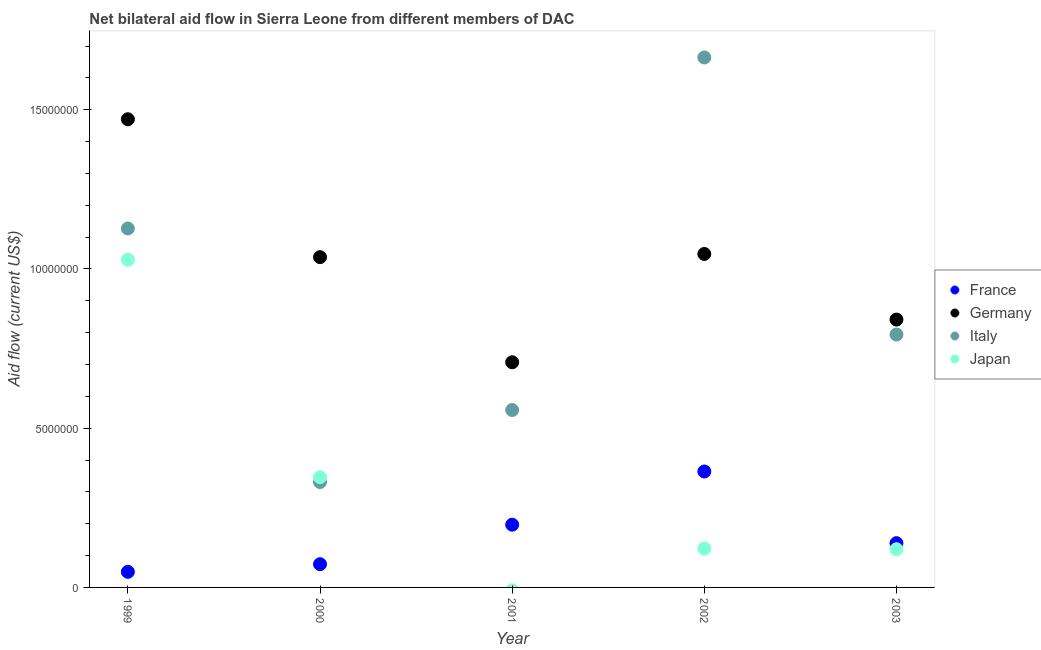How many different coloured dotlines are there?
Your answer should be compact. 4. Is the number of dotlines equal to the number of legend labels?
Your answer should be compact. No. What is the amount of aid given by germany in 2001?
Offer a terse response. 7.07e+06. Across all years, what is the maximum amount of aid given by italy?
Your response must be concise. 1.66e+07. Across all years, what is the minimum amount of aid given by italy?
Your response must be concise. 3.31e+06. What is the total amount of aid given by germany in the graph?
Your answer should be compact. 5.10e+07. What is the difference between the amount of aid given by germany in 2000 and that in 2003?
Provide a short and direct response. 1.96e+06. What is the difference between the amount of aid given by france in 2003 and the amount of aid given by germany in 2000?
Keep it short and to the point. -8.98e+06. What is the average amount of aid given by italy per year?
Give a very brief answer. 8.95e+06. In the year 1999, what is the difference between the amount of aid given by germany and amount of aid given by japan?
Provide a short and direct response. 4.41e+06. What is the ratio of the amount of aid given by france in 2000 to that in 2002?
Provide a succinct answer. 0.2. What is the difference between the highest and the second highest amount of aid given by italy?
Ensure brevity in your answer.  5.37e+06. What is the difference between the highest and the lowest amount of aid given by france?
Offer a terse response. 3.15e+06. In how many years, is the amount of aid given by italy greater than the average amount of aid given by italy taken over all years?
Ensure brevity in your answer.  2. Is it the case that in every year, the sum of the amount of aid given by italy and amount of aid given by france is greater than the sum of amount of aid given by germany and amount of aid given by japan?
Give a very brief answer. No. Is it the case that in every year, the sum of the amount of aid given by france and amount of aid given by germany is greater than the amount of aid given by italy?
Your response must be concise. No. Does the amount of aid given by japan monotonically increase over the years?
Ensure brevity in your answer.  No. Is the amount of aid given by france strictly greater than the amount of aid given by italy over the years?
Provide a succinct answer. No. Is the amount of aid given by japan strictly less than the amount of aid given by germany over the years?
Give a very brief answer. Yes. How many years are there in the graph?
Your answer should be very brief. 5. What is the difference between two consecutive major ticks on the Y-axis?
Make the answer very short. 5.00e+06. Does the graph contain any zero values?
Provide a succinct answer. Yes. Does the graph contain grids?
Ensure brevity in your answer.  No. Where does the legend appear in the graph?
Your answer should be very brief. Center right. How many legend labels are there?
Your answer should be compact. 4. How are the legend labels stacked?
Offer a terse response. Vertical. What is the title of the graph?
Give a very brief answer. Net bilateral aid flow in Sierra Leone from different members of DAC. Does "Other greenhouse gases" appear as one of the legend labels in the graph?
Keep it short and to the point. No. What is the label or title of the X-axis?
Your response must be concise. Year. What is the label or title of the Y-axis?
Provide a succinct answer. Aid flow (current US$). What is the Aid flow (current US$) of Germany in 1999?
Keep it short and to the point. 1.47e+07. What is the Aid flow (current US$) in Italy in 1999?
Make the answer very short. 1.13e+07. What is the Aid flow (current US$) in Japan in 1999?
Make the answer very short. 1.03e+07. What is the Aid flow (current US$) of France in 2000?
Keep it short and to the point. 7.30e+05. What is the Aid flow (current US$) in Germany in 2000?
Make the answer very short. 1.04e+07. What is the Aid flow (current US$) of Italy in 2000?
Provide a succinct answer. 3.31e+06. What is the Aid flow (current US$) of Japan in 2000?
Ensure brevity in your answer.  3.46e+06. What is the Aid flow (current US$) in France in 2001?
Give a very brief answer. 1.97e+06. What is the Aid flow (current US$) of Germany in 2001?
Keep it short and to the point. 7.07e+06. What is the Aid flow (current US$) of Italy in 2001?
Your response must be concise. 5.57e+06. What is the Aid flow (current US$) of Japan in 2001?
Keep it short and to the point. 0. What is the Aid flow (current US$) in France in 2002?
Make the answer very short. 3.64e+06. What is the Aid flow (current US$) in Germany in 2002?
Keep it short and to the point. 1.05e+07. What is the Aid flow (current US$) of Italy in 2002?
Provide a short and direct response. 1.66e+07. What is the Aid flow (current US$) in Japan in 2002?
Provide a succinct answer. 1.22e+06. What is the Aid flow (current US$) in France in 2003?
Keep it short and to the point. 1.39e+06. What is the Aid flow (current US$) of Germany in 2003?
Make the answer very short. 8.41e+06. What is the Aid flow (current US$) in Italy in 2003?
Give a very brief answer. 7.94e+06. What is the Aid flow (current US$) in Japan in 2003?
Keep it short and to the point. 1.20e+06. Across all years, what is the maximum Aid flow (current US$) in France?
Make the answer very short. 3.64e+06. Across all years, what is the maximum Aid flow (current US$) in Germany?
Ensure brevity in your answer.  1.47e+07. Across all years, what is the maximum Aid flow (current US$) of Italy?
Your answer should be compact. 1.66e+07. Across all years, what is the maximum Aid flow (current US$) in Japan?
Keep it short and to the point. 1.03e+07. Across all years, what is the minimum Aid flow (current US$) in Germany?
Ensure brevity in your answer.  7.07e+06. Across all years, what is the minimum Aid flow (current US$) in Italy?
Ensure brevity in your answer.  3.31e+06. Across all years, what is the minimum Aid flow (current US$) of Japan?
Provide a short and direct response. 0. What is the total Aid flow (current US$) of France in the graph?
Give a very brief answer. 8.22e+06. What is the total Aid flow (current US$) of Germany in the graph?
Your answer should be compact. 5.10e+07. What is the total Aid flow (current US$) of Italy in the graph?
Offer a terse response. 4.47e+07. What is the total Aid flow (current US$) of Japan in the graph?
Provide a succinct answer. 1.62e+07. What is the difference between the Aid flow (current US$) of France in 1999 and that in 2000?
Your answer should be compact. -2.40e+05. What is the difference between the Aid flow (current US$) in Germany in 1999 and that in 2000?
Keep it short and to the point. 4.33e+06. What is the difference between the Aid flow (current US$) in Italy in 1999 and that in 2000?
Your answer should be compact. 7.96e+06. What is the difference between the Aid flow (current US$) of Japan in 1999 and that in 2000?
Provide a short and direct response. 6.83e+06. What is the difference between the Aid flow (current US$) of France in 1999 and that in 2001?
Offer a terse response. -1.48e+06. What is the difference between the Aid flow (current US$) in Germany in 1999 and that in 2001?
Offer a very short reply. 7.63e+06. What is the difference between the Aid flow (current US$) of Italy in 1999 and that in 2001?
Ensure brevity in your answer.  5.70e+06. What is the difference between the Aid flow (current US$) in France in 1999 and that in 2002?
Your response must be concise. -3.15e+06. What is the difference between the Aid flow (current US$) of Germany in 1999 and that in 2002?
Provide a succinct answer. 4.23e+06. What is the difference between the Aid flow (current US$) in Italy in 1999 and that in 2002?
Your answer should be very brief. -5.37e+06. What is the difference between the Aid flow (current US$) in Japan in 1999 and that in 2002?
Provide a succinct answer. 9.07e+06. What is the difference between the Aid flow (current US$) of France in 1999 and that in 2003?
Give a very brief answer. -9.00e+05. What is the difference between the Aid flow (current US$) of Germany in 1999 and that in 2003?
Make the answer very short. 6.29e+06. What is the difference between the Aid flow (current US$) in Italy in 1999 and that in 2003?
Keep it short and to the point. 3.33e+06. What is the difference between the Aid flow (current US$) in Japan in 1999 and that in 2003?
Your answer should be very brief. 9.09e+06. What is the difference between the Aid flow (current US$) in France in 2000 and that in 2001?
Give a very brief answer. -1.24e+06. What is the difference between the Aid flow (current US$) of Germany in 2000 and that in 2001?
Offer a terse response. 3.30e+06. What is the difference between the Aid flow (current US$) in Italy in 2000 and that in 2001?
Provide a succinct answer. -2.26e+06. What is the difference between the Aid flow (current US$) in France in 2000 and that in 2002?
Provide a short and direct response. -2.91e+06. What is the difference between the Aid flow (current US$) of Germany in 2000 and that in 2002?
Keep it short and to the point. -1.00e+05. What is the difference between the Aid flow (current US$) of Italy in 2000 and that in 2002?
Provide a succinct answer. -1.33e+07. What is the difference between the Aid flow (current US$) of Japan in 2000 and that in 2002?
Keep it short and to the point. 2.24e+06. What is the difference between the Aid flow (current US$) of France in 2000 and that in 2003?
Give a very brief answer. -6.60e+05. What is the difference between the Aid flow (current US$) in Germany in 2000 and that in 2003?
Your response must be concise. 1.96e+06. What is the difference between the Aid flow (current US$) in Italy in 2000 and that in 2003?
Offer a very short reply. -4.63e+06. What is the difference between the Aid flow (current US$) in Japan in 2000 and that in 2003?
Make the answer very short. 2.26e+06. What is the difference between the Aid flow (current US$) of France in 2001 and that in 2002?
Offer a terse response. -1.67e+06. What is the difference between the Aid flow (current US$) in Germany in 2001 and that in 2002?
Give a very brief answer. -3.40e+06. What is the difference between the Aid flow (current US$) in Italy in 2001 and that in 2002?
Offer a terse response. -1.11e+07. What is the difference between the Aid flow (current US$) of France in 2001 and that in 2003?
Keep it short and to the point. 5.80e+05. What is the difference between the Aid flow (current US$) in Germany in 2001 and that in 2003?
Your answer should be very brief. -1.34e+06. What is the difference between the Aid flow (current US$) of Italy in 2001 and that in 2003?
Your answer should be compact. -2.37e+06. What is the difference between the Aid flow (current US$) of France in 2002 and that in 2003?
Offer a very short reply. 2.25e+06. What is the difference between the Aid flow (current US$) in Germany in 2002 and that in 2003?
Give a very brief answer. 2.06e+06. What is the difference between the Aid flow (current US$) of Italy in 2002 and that in 2003?
Provide a short and direct response. 8.70e+06. What is the difference between the Aid flow (current US$) of France in 1999 and the Aid flow (current US$) of Germany in 2000?
Provide a short and direct response. -9.88e+06. What is the difference between the Aid flow (current US$) of France in 1999 and the Aid flow (current US$) of Italy in 2000?
Your answer should be compact. -2.82e+06. What is the difference between the Aid flow (current US$) of France in 1999 and the Aid flow (current US$) of Japan in 2000?
Offer a very short reply. -2.97e+06. What is the difference between the Aid flow (current US$) of Germany in 1999 and the Aid flow (current US$) of Italy in 2000?
Ensure brevity in your answer.  1.14e+07. What is the difference between the Aid flow (current US$) of Germany in 1999 and the Aid flow (current US$) of Japan in 2000?
Provide a succinct answer. 1.12e+07. What is the difference between the Aid flow (current US$) in Italy in 1999 and the Aid flow (current US$) in Japan in 2000?
Make the answer very short. 7.81e+06. What is the difference between the Aid flow (current US$) of France in 1999 and the Aid flow (current US$) of Germany in 2001?
Provide a short and direct response. -6.58e+06. What is the difference between the Aid flow (current US$) of France in 1999 and the Aid flow (current US$) of Italy in 2001?
Give a very brief answer. -5.08e+06. What is the difference between the Aid flow (current US$) of Germany in 1999 and the Aid flow (current US$) of Italy in 2001?
Provide a short and direct response. 9.13e+06. What is the difference between the Aid flow (current US$) in France in 1999 and the Aid flow (current US$) in Germany in 2002?
Your response must be concise. -9.98e+06. What is the difference between the Aid flow (current US$) in France in 1999 and the Aid flow (current US$) in Italy in 2002?
Provide a succinct answer. -1.62e+07. What is the difference between the Aid flow (current US$) of France in 1999 and the Aid flow (current US$) of Japan in 2002?
Your response must be concise. -7.30e+05. What is the difference between the Aid flow (current US$) in Germany in 1999 and the Aid flow (current US$) in Italy in 2002?
Ensure brevity in your answer.  -1.94e+06. What is the difference between the Aid flow (current US$) in Germany in 1999 and the Aid flow (current US$) in Japan in 2002?
Provide a short and direct response. 1.35e+07. What is the difference between the Aid flow (current US$) of Italy in 1999 and the Aid flow (current US$) of Japan in 2002?
Make the answer very short. 1.00e+07. What is the difference between the Aid flow (current US$) of France in 1999 and the Aid flow (current US$) of Germany in 2003?
Your answer should be very brief. -7.92e+06. What is the difference between the Aid flow (current US$) of France in 1999 and the Aid flow (current US$) of Italy in 2003?
Make the answer very short. -7.45e+06. What is the difference between the Aid flow (current US$) in France in 1999 and the Aid flow (current US$) in Japan in 2003?
Offer a terse response. -7.10e+05. What is the difference between the Aid flow (current US$) of Germany in 1999 and the Aid flow (current US$) of Italy in 2003?
Give a very brief answer. 6.76e+06. What is the difference between the Aid flow (current US$) in Germany in 1999 and the Aid flow (current US$) in Japan in 2003?
Offer a terse response. 1.35e+07. What is the difference between the Aid flow (current US$) of Italy in 1999 and the Aid flow (current US$) of Japan in 2003?
Your answer should be compact. 1.01e+07. What is the difference between the Aid flow (current US$) of France in 2000 and the Aid flow (current US$) of Germany in 2001?
Provide a succinct answer. -6.34e+06. What is the difference between the Aid flow (current US$) in France in 2000 and the Aid flow (current US$) in Italy in 2001?
Your answer should be compact. -4.84e+06. What is the difference between the Aid flow (current US$) of Germany in 2000 and the Aid flow (current US$) of Italy in 2001?
Your response must be concise. 4.80e+06. What is the difference between the Aid flow (current US$) in France in 2000 and the Aid flow (current US$) in Germany in 2002?
Offer a terse response. -9.74e+06. What is the difference between the Aid flow (current US$) in France in 2000 and the Aid flow (current US$) in Italy in 2002?
Your answer should be compact. -1.59e+07. What is the difference between the Aid flow (current US$) in France in 2000 and the Aid flow (current US$) in Japan in 2002?
Offer a very short reply. -4.90e+05. What is the difference between the Aid flow (current US$) in Germany in 2000 and the Aid flow (current US$) in Italy in 2002?
Provide a short and direct response. -6.27e+06. What is the difference between the Aid flow (current US$) of Germany in 2000 and the Aid flow (current US$) of Japan in 2002?
Provide a short and direct response. 9.15e+06. What is the difference between the Aid flow (current US$) in Italy in 2000 and the Aid flow (current US$) in Japan in 2002?
Give a very brief answer. 2.09e+06. What is the difference between the Aid flow (current US$) in France in 2000 and the Aid flow (current US$) in Germany in 2003?
Offer a terse response. -7.68e+06. What is the difference between the Aid flow (current US$) of France in 2000 and the Aid flow (current US$) of Italy in 2003?
Your answer should be compact. -7.21e+06. What is the difference between the Aid flow (current US$) in France in 2000 and the Aid flow (current US$) in Japan in 2003?
Offer a very short reply. -4.70e+05. What is the difference between the Aid flow (current US$) of Germany in 2000 and the Aid flow (current US$) of Italy in 2003?
Your answer should be very brief. 2.43e+06. What is the difference between the Aid flow (current US$) of Germany in 2000 and the Aid flow (current US$) of Japan in 2003?
Give a very brief answer. 9.17e+06. What is the difference between the Aid flow (current US$) in Italy in 2000 and the Aid flow (current US$) in Japan in 2003?
Your answer should be compact. 2.11e+06. What is the difference between the Aid flow (current US$) of France in 2001 and the Aid flow (current US$) of Germany in 2002?
Your answer should be compact. -8.50e+06. What is the difference between the Aid flow (current US$) of France in 2001 and the Aid flow (current US$) of Italy in 2002?
Your response must be concise. -1.47e+07. What is the difference between the Aid flow (current US$) in France in 2001 and the Aid flow (current US$) in Japan in 2002?
Your answer should be very brief. 7.50e+05. What is the difference between the Aid flow (current US$) in Germany in 2001 and the Aid flow (current US$) in Italy in 2002?
Ensure brevity in your answer.  -9.57e+06. What is the difference between the Aid flow (current US$) in Germany in 2001 and the Aid flow (current US$) in Japan in 2002?
Offer a very short reply. 5.85e+06. What is the difference between the Aid flow (current US$) in Italy in 2001 and the Aid flow (current US$) in Japan in 2002?
Keep it short and to the point. 4.35e+06. What is the difference between the Aid flow (current US$) in France in 2001 and the Aid flow (current US$) in Germany in 2003?
Your answer should be very brief. -6.44e+06. What is the difference between the Aid flow (current US$) of France in 2001 and the Aid flow (current US$) of Italy in 2003?
Keep it short and to the point. -5.97e+06. What is the difference between the Aid flow (current US$) in France in 2001 and the Aid flow (current US$) in Japan in 2003?
Your answer should be very brief. 7.70e+05. What is the difference between the Aid flow (current US$) of Germany in 2001 and the Aid flow (current US$) of Italy in 2003?
Your answer should be compact. -8.70e+05. What is the difference between the Aid flow (current US$) in Germany in 2001 and the Aid flow (current US$) in Japan in 2003?
Offer a terse response. 5.87e+06. What is the difference between the Aid flow (current US$) in Italy in 2001 and the Aid flow (current US$) in Japan in 2003?
Your response must be concise. 4.37e+06. What is the difference between the Aid flow (current US$) in France in 2002 and the Aid flow (current US$) in Germany in 2003?
Provide a succinct answer. -4.77e+06. What is the difference between the Aid flow (current US$) of France in 2002 and the Aid flow (current US$) of Italy in 2003?
Provide a short and direct response. -4.30e+06. What is the difference between the Aid flow (current US$) in France in 2002 and the Aid flow (current US$) in Japan in 2003?
Give a very brief answer. 2.44e+06. What is the difference between the Aid flow (current US$) of Germany in 2002 and the Aid flow (current US$) of Italy in 2003?
Your answer should be compact. 2.53e+06. What is the difference between the Aid flow (current US$) in Germany in 2002 and the Aid flow (current US$) in Japan in 2003?
Your answer should be compact. 9.27e+06. What is the difference between the Aid flow (current US$) in Italy in 2002 and the Aid flow (current US$) in Japan in 2003?
Make the answer very short. 1.54e+07. What is the average Aid flow (current US$) in France per year?
Provide a short and direct response. 1.64e+06. What is the average Aid flow (current US$) of Germany per year?
Give a very brief answer. 1.02e+07. What is the average Aid flow (current US$) of Italy per year?
Your response must be concise. 8.95e+06. What is the average Aid flow (current US$) in Japan per year?
Keep it short and to the point. 3.23e+06. In the year 1999, what is the difference between the Aid flow (current US$) of France and Aid flow (current US$) of Germany?
Ensure brevity in your answer.  -1.42e+07. In the year 1999, what is the difference between the Aid flow (current US$) in France and Aid flow (current US$) in Italy?
Provide a succinct answer. -1.08e+07. In the year 1999, what is the difference between the Aid flow (current US$) in France and Aid flow (current US$) in Japan?
Offer a terse response. -9.80e+06. In the year 1999, what is the difference between the Aid flow (current US$) of Germany and Aid flow (current US$) of Italy?
Provide a short and direct response. 3.43e+06. In the year 1999, what is the difference between the Aid flow (current US$) in Germany and Aid flow (current US$) in Japan?
Your answer should be compact. 4.41e+06. In the year 1999, what is the difference between the Aid flow (current US$) of Italy and Aid flow (current US$) of Japan?
Ensure brevity in your answer.  9.80e+05. In the year 2000, what is the difference between the Aid flow (current US$) in France and Aid flow (current US$) in Germany?
Provide a short and direct response. -9.64e+06. In the year 2000, what is the difference between the Aid flow (current US$) in France and Aid flow (current US$) in Italy?
Offer a terse response. -2.58e+06. In the year 2000, what is the difference between the Aid flow (current US$) in France and Aid flow (current US$) in Japan?
Offer a terse response. -2.73e+06. In the year 2000, what is the difference between the Aid flow (current US$) of Germany and Aid flow (current US$) of Italy?
Ensure brevity in your answer.  7.06e+06. In the year 2000, what is the difference between the Aid flow (current US$) of Germany and Aid flow (current US$) of Japan?
Make the answer very short. 6.91e+06. In the year 2000, what is the difference between the Aid flow (current US$) in Italy and Aid flow (current US$) in Japan?
Provide a succinct answer. -1.50e+05. In the year 2001, what is the difference between the Aid flow (current US$) in France and Aid flow (current US$) in Germany?
Give a very brief answer. -5.10e+06. In the year 2001, what is the difference between the Aid flow (current US$) in France and Aid flow (current US$) in Italy?
Your answer should be very brief. -3.60e+06. In the year 2001, what is the difference between the Aid flow (current US$) of Germany and Aid flow (current US$) of Italy?
Give a very brief answer. 1.50e+06. In the year 2002, what is the difference between the Aid flow (current US$) of France and Aid flow (current US$) of Germany?
Your answer should be compact. -6.83e+06. In the year 2002, what is the difference between the Aid flow (current US$) in France and Aid flow (current US$) in Italy?
Your answer should be compact. -1.30e+07. In the year 2002, what is the difference between the Aid flow (current US$) in France and Aid flow (current US$) in Japan?
Provide a short and direct response. 2.42e+06. In the year 2002, what is the difference between the Aid flow (current US$) of Germany and Aid flow (current US$) of Italy?
Offer a terse response. -6.17e+06. In the year 2002, what is the difference between the Aid flow (current US$) in Germany and Aid flow (current US$) in Japan?
Give a very brief answer. 9.25e+06. In the year 2002, what is the difference between the Aid flow (current US$) in Italy and Aid flow (current US$) in Japan?
Ensure brevity in your answer.  1.54e+07. In the year 2003, what is the difference between the Aid flow (current US$) of France and Aid flow (current US$) of Germany?
Ensure brevity in your answer.  -7.02e+06. In the year 2003, what is the difference between the Aid flow (current US$) in France and Aid flow (current US$) in Italy?
Provide a succinct answer. -6.55e+06. In the year 2003, what is the difference between the Aid flow (current US$) of France and Aid flow (current US$) of Japan?
Ensure brevity in your answer.  1.90e+05. In the year 2003, what is the difference between the Aid flow (current US$) of Germany and Aid flow (current US$) of Japan?
Offer a terse response. 7.21e+06. In the year 2003, what is the difference between the Aid flow (current US$) in Italy and Aid flow (current US$) in Japan?
Offer a very short reply. 6.74e+06. What is the ratio of the Aid flow (current US$) in France in 1999 to that in 2000?
Make the answer very short. 0.67. What is the ratio of the Aid flow (current US$) of Germany in 1999 to that in 2000?
Provide a short and direct response. 1.42. What is the ratio of the Aid flow (current US$) in Italy in 1999 to that in 2000?
Provide a short and direct response. 3.4. What is the ratio of the Aid flow (current US$) of Japan in 1999 to that in 2000?
Make the answer very short. 2.97. What is the ratio of the Aid flow (current US$) in France in 1999 to that in 2001?
Offer a very short reply. 0.25. What is the ratio of the Aid flow (current US$) of Germany in 1999 to that in 2001?
Your response must be concise. 2.08. What is the ratio of the Aid flow (current US$) in Italy in 1999 to that in 2001?
Your answer should be compact. 2.02. What is the ratio of the Aid flow (current US$) of France in 1999 to that in 2002?
Your answer should be very brief. 0.13. What is the ratio of the Aid flow (current US$) in Germany in 1999 to that in 2002?
Make the answer very short. 1.4. What is the ratio of the Aid flow (current US$) in Italy in 1999 to that in 2002?
Offer a terse response. 0.68. What is the ratio of the Aid flow (current US$) in Japan in 1999 to that in 2002?
Provide a short and direct response. 8.43. What is the ratio of the Aid flow (current US$) in France in 1999 to that in 2003?
Ensure brevity in your answer.  0.35. What is the ratio of the Aid flow (current US$) in Germany in 1999 to that in 2003?
Make the answer very short. 1.75. What is the ratio of the Aid flow (current US$) of Italy in 1999 to that in 2003?
Your response must be concise. 1.42. What is the ratio of the Aid flow (current US$) of Japan in 1999 to that in 2003?
Ensure brevity in your answer.  8.57. What is the ratio of the Aid flow (current US$) in France in 2000 to that in 2001?
Keep it short and to the point. 0.37. What is the ratio of the Aid flow (current US$) in Germany in 2000 to that in 2001?
Give a very brief answer. 1.47. What is the ratio of the Aid flow (current US$) in Italy in 2000 to that in 2001?
Offer a very short reply. 0.59. What is the ratio of the Aid flow (current US$) of France in 2000 to that in 2002?
Offer a very short reply. 0.2. What is the ratio of the Aid flow (current US$) of Italy in 2000 to that in 2002?
Make the answer very short. 0.2. What is the ratio of the Aid flow (current US$) of Japan in 2000 to that in 2002?
Your answer should be very brief. 2.84. What is the ratio of the Aid flow (current US$) of France in 2000 to that in 2003?
Your answer should be very brief. 0.53. What is the ratio of the Aid flow (current US$) in Germany in 2000 to that in 2003?
Offer a very short reply. 1.23. What is the ratio of the Aid flow (current US$) of Italy in 2000 to that in 2003?
Offer a terse response. 0.42. What is the ratio of the Aid flow (current US$) of Japan in 2000 to that in 2003?
Provide a succinct answer. 2.88. What is the ratio of the Aid flow (current US$) of France in 2001 to that in 2002?
Your answer should be very brief. 0.54. What is the ratio of the Aid flow (current US$) in Germany in 2001 to that in 2002?
Ensure brevity in your answer.  0.68. What is the ratio of the Aid flow (current US$) in Italy in 2001 to that in 2002?
Your response must be concise. 0.33. What is the ratio of the Aid flow (current US$) of France in 2001 to that in 2003?
Your response must be concise. 1.42. What is the ratio of the Aid flow (current US$) of Germany in 2001 to that in 2003?
Give a very brief answer. 0.84. What is the ratio of the Aid flow (current US$) of Italy in 2001 to that in 2003?
Provide a short and direct response. 0.7. What is the ratio of the Aid flow (current US$) of France in 2002 to that in 2003?
Give a very brief answer. 2.62. What is the ratio of the Aid flow (current US$) in Germany in 2002 to that in 2003?
Make the answer very short. 1.24. What is the ratio of the Aid flow (current US$) of Italy in 2002 to that in 2003?
Ensure brevity in your answer.  2.1. What is the ratio of the Aid flow (current US$) in Japan in 2002 to that in 2003?
Your answer should be very brief. 1.02. What is the difference between the highest and the second highest Aid flow (current US$) of France?
Make the answer very short. 1.67e+06. What is the difference between the highest and the second highest Aid flow (current US$) of Germany?
Provide a succinct answer. 4.23e+06. What is the difference between the highest and the second highest Aid flow (current US$) of Italy?
Make the answer very short. 5.37e+06. What is the difference between the highest and the second highest Aid flow (current US$) of Japan?
Offer a very short reply. 6.83e+06. What is the difference between the highest and the lowest Aid flow (current US$) of France?
Offer a terse response. 3.15e+06. What is the difference between the highest and the lowest Aid flow (current US$) in Germany?
Your response must be concise. 7.63e+06. What is the difference between the highest and the lowest Aid flow (current US$) in Italy?
Make the answer very short. 1.33e+07. What is the difference between the highest and the lowest Aid flow (current US$) of Japan?
Offer a terse response. 1.03e+07. 